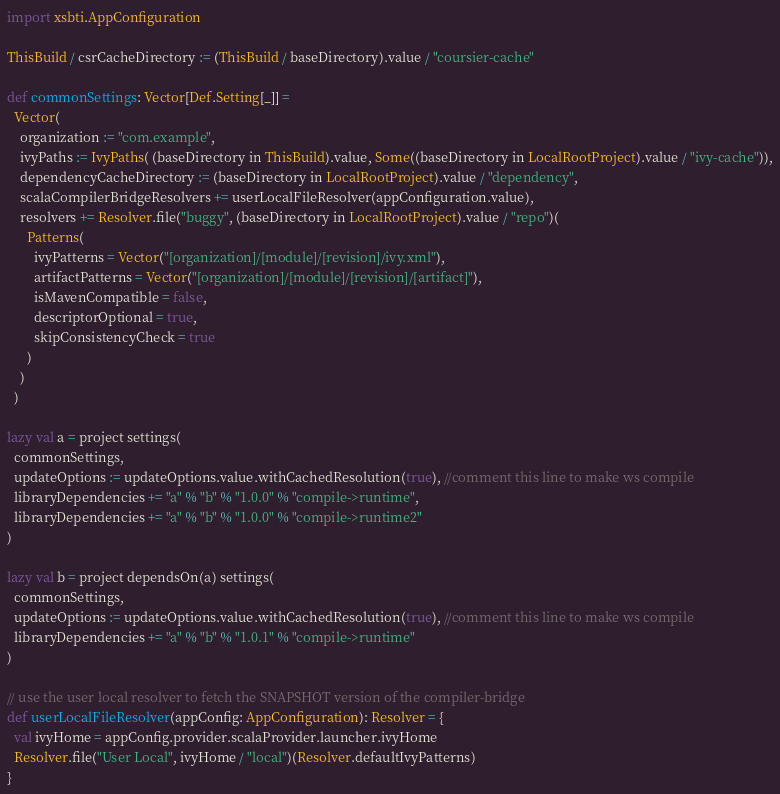Convert code to text. <code><loc_0><loc_0><loc_500><loc_500><_Scala_>import xsbti.AppConfiguration

ThisBuild / csrCacheDirectory := (ThisBuild / baseDirectory).value / "coursier-cache"

def commonSettings: Vector[Def.Setting[_]] =
  Vector(
    organization := "com.example",
    ivyPaths := IvyPaths( (baseDirectory in ThisBuild).value, Some((baseDirectory in LocalRootProject).value / "ivy-cache")),
    dependencyCacheDirectory := (baseDirectory in LocalRootProject).value / "dependency",
    scalaCompilerBridgeResolvers += userLocalFileResolver(appConfiguration.value),
    resolvers += Resolver.file("buggy", (baseDirectory in LocalRootProject).value / "repo")(
      Patterns(
        ivyPatterns = Vector("[organization]/[module]/[revision]/ivy.xml"),
        artifactPatterns = Vector("[organization]/[module]/[revision]/[artifact]"),
        isMavenCompatible = false,
        descriptorOptional = true,
        skipConsistencyCheck = true
      )
    )
  )

lazy val a = project settings(
  commonSettings,
  updateOptions := updateOptions.value.withCachedResolution(true), //comment this line to make ws compile
  libraryDependencies += "a" % "b" % "1.0.0" % "compile->runtime",
  libraryDependencies += "a" % "b" % "1.0.0" % "compile->runtime2"
)

lazy val b = project dependsOn(a) settings(
  commonSettings,
  updateOptions := updateOptions.value.withCachedResolution(true), //comment this line to make ws compile
  libraryDependencies += "a" % "b" % "1.0.1" % "compile->runtime"
)

// use the user local resolver to fetch the SNAPSHOT version of the compiler-bridge
def userLocalFileResolver(appConfig: AppConfiguration): Resolver = {
  val ivyHome = appConfig.provider.scalaProvider.launcher.ivyHome
  Resolver.file("User Local", ivyHome / "local")(Resolver.defaultIvyPatterns)
}
</code> 